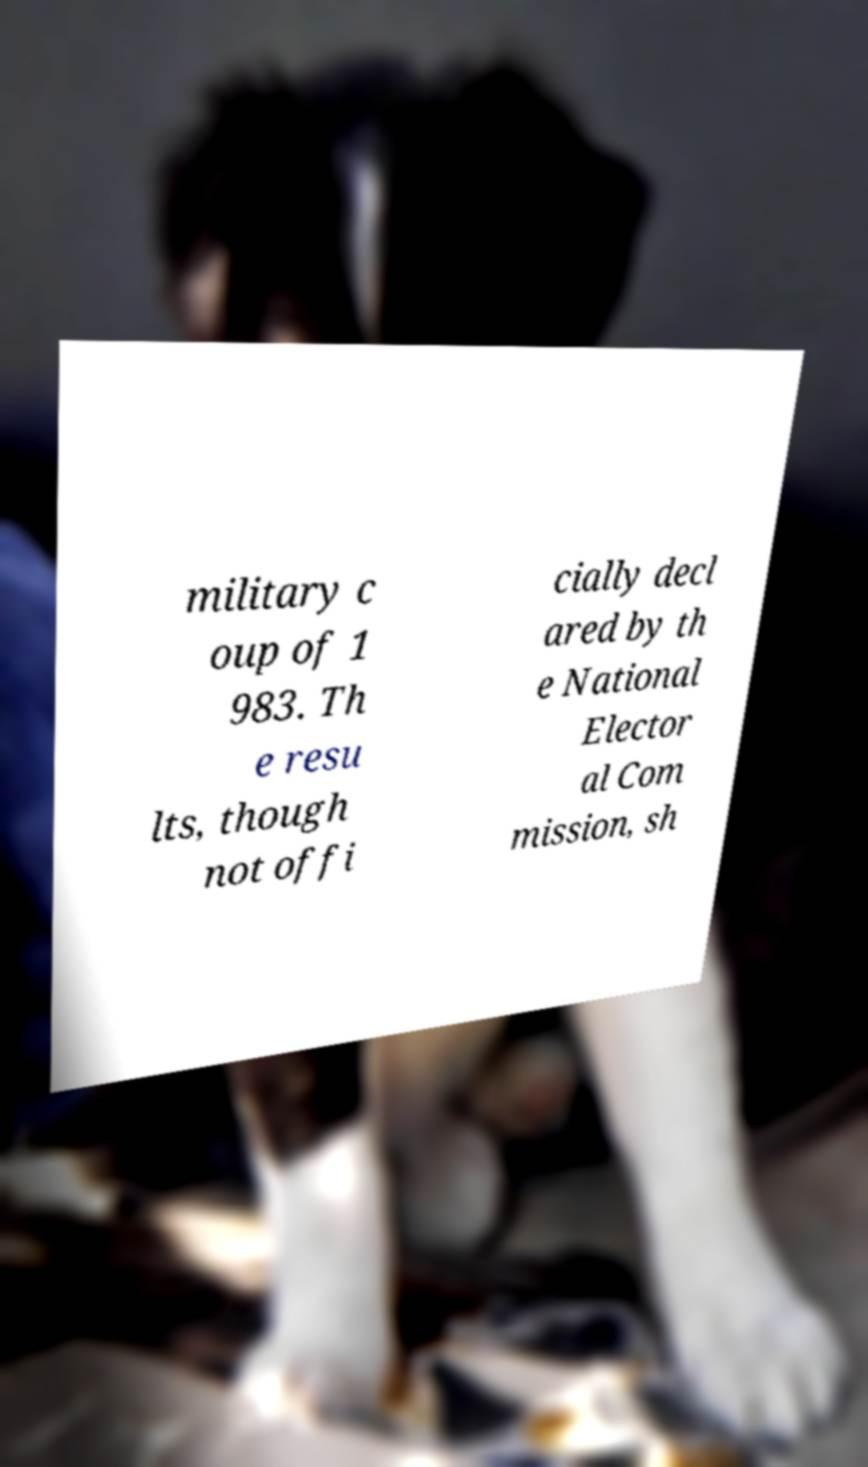There's text embedded in this image that I need extracted. Can you transcribe it verbatim? military c oup of 1 983. Th e resu lts, though not offi cially decl ared by th e National Elector al Com mission, sh 